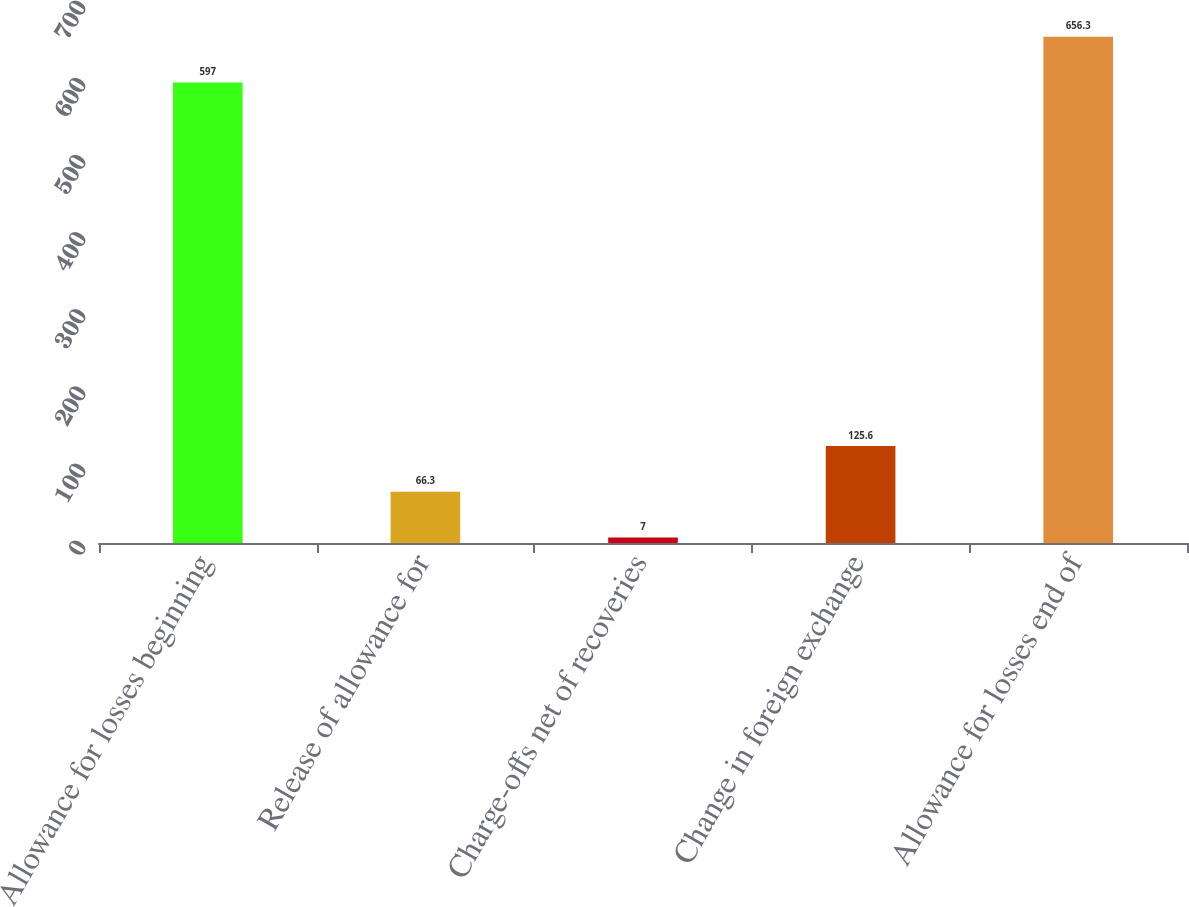Convert chart. <chart><loc_0><loc_0><loc_500><loc_500><bar_chart><fcel>Allowance for losses beginning<fcel>Release of allowance for<fcel>Charge-offs net of recoveries<fcel>Change in foreign exchange<fcel>Allowance for losses end of<nl><fcel>597<fcel>66.3<fcel>7<fcel>125.6<fcel>656.3<nl></chart> 